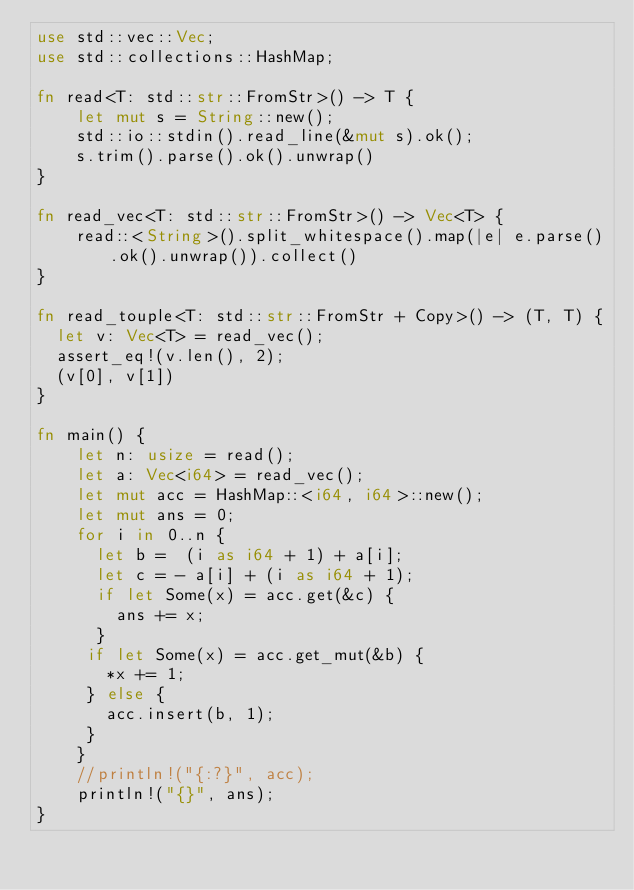Convert code to text. <code><loc_0><loc_0><loc_500><loc_500><_Rust_>use std::vec::Vec;
use std::collections::HashMap;

fn read<T: std::str::FromStr>() -> T {
    let mut s = String::new();
    std::io::stdin().read_line(&mut s).ok();
    s.trim().parse().ok().unwrap()
}

fn read_vec<T: std::str::FromStr>() -> Vec<T> {
    read::<String>().split_whitespace().map(|e| e.parse().ok().unwrap()).collect()
}

fn read_touple<T: std::str::FromStr + Copy>() -> (T, T) {
  let v: Vec<T> = read_vec();
  assert_eq!(v.len(), 2);
  (v[0], v[1])
}

fn main() {
    let n: usize = read();
    let a: Vec<i64> = read_vec();
    let mut acc = HashMap::<i64, i64>::new();
    let mut ans = 0;
    for i in 0..n {
      let b =  (i as i64 + 1) + a[i];
      let c = - a[i] + (i as i64 + 1);
      if let Some(x) = acc.get(&c) {
        ans += x;
      }
     if let Some(x) = acc.get_mut(&b) {
       *x += 1;
     } else {
       acc.insert(b, 1);
     }
    }
    //println!("{:?}", acc);
    println!("{}", ans);
}
</code> 